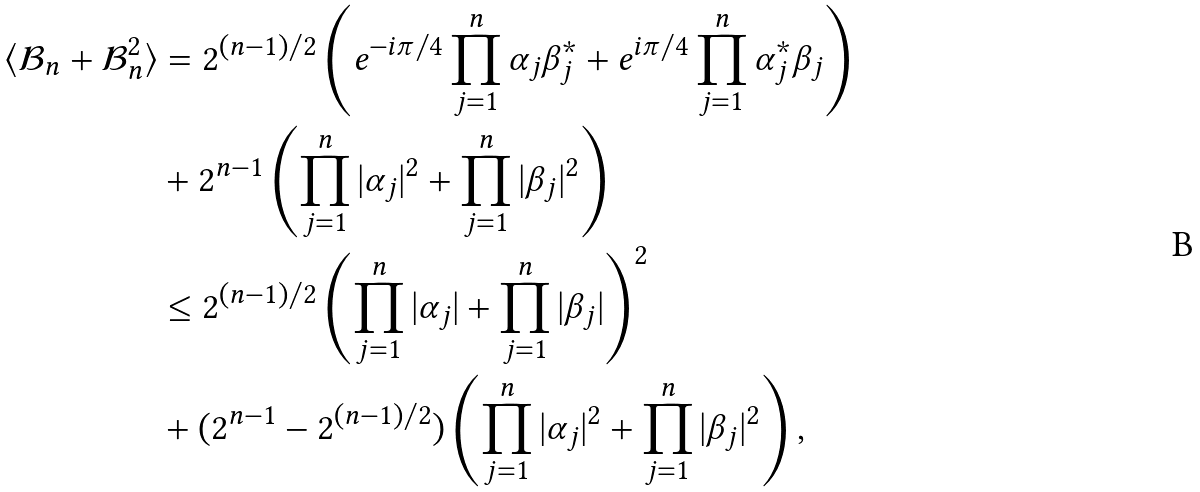<formula> <loc_0><loc_0><loc_500><loc_500>\langle \mathcal { B } _ { n } + \mathcal { B } ^ { 2 } _ { n } \rangle & = 2 ^ { ( n - 1 ) / 2 } \left ( e ^ { - i \pi / 4 } \prod ^ { n } _ { j = 1 } \alpha _ { j } \beta ^ { * } _ { j } + e ^ { i \pi / 4 } \prod ^ { n } _ { j = 1 } \alpha ^ { * } _ { j } \beta _ { j } \right ) \\ & + 2 ^ { n - 1 } \left ( \prod ^ { n } _ { j = 1 } | \alpha _ { j } | ^ { 2 } + \prod ^ { n } _ { j = 1 } | \beta _ { j } | ^ { 2 } \right ) \\ & \leq 2 ^ { ( n - 1 ) / 2 } \left ( \prod ^ { n } _ { j = 1 } | \alpha _ { j } | + \prod ^ { n } _ { j = 1 } | \beta _ { j } | \right ) ^ { 2 } \\ & + ( 2 ^ { n - 1 } - 2 ^ { ( n - 1 ) / 2 } ) \left ( \prod ^ { n } _ { j = 1 } | \alpha _ { j } | ^ { 2 } + \prod ^ { n } _ { j = 1 } | \beta _ { j } | ^ { 2 } \right ) ,</formula> 